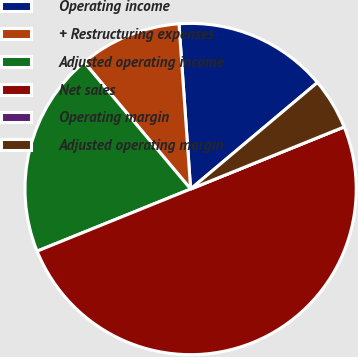<chart> <loc_0><loc_0><loc_500><loc_500><pie_chart><fcel>Operating income<fcel>+ Restructuring expenses<fcel>Adjusted operating income<fcel>Net sales<fcel>Operating margin<fcel>Adjusted operating margin<nl><fcel>15.0%<fcel>10.0%<fcel>20.0%<fcel>50.0%<fcel>0.0%<fcel>5.0%<nl></chart> 